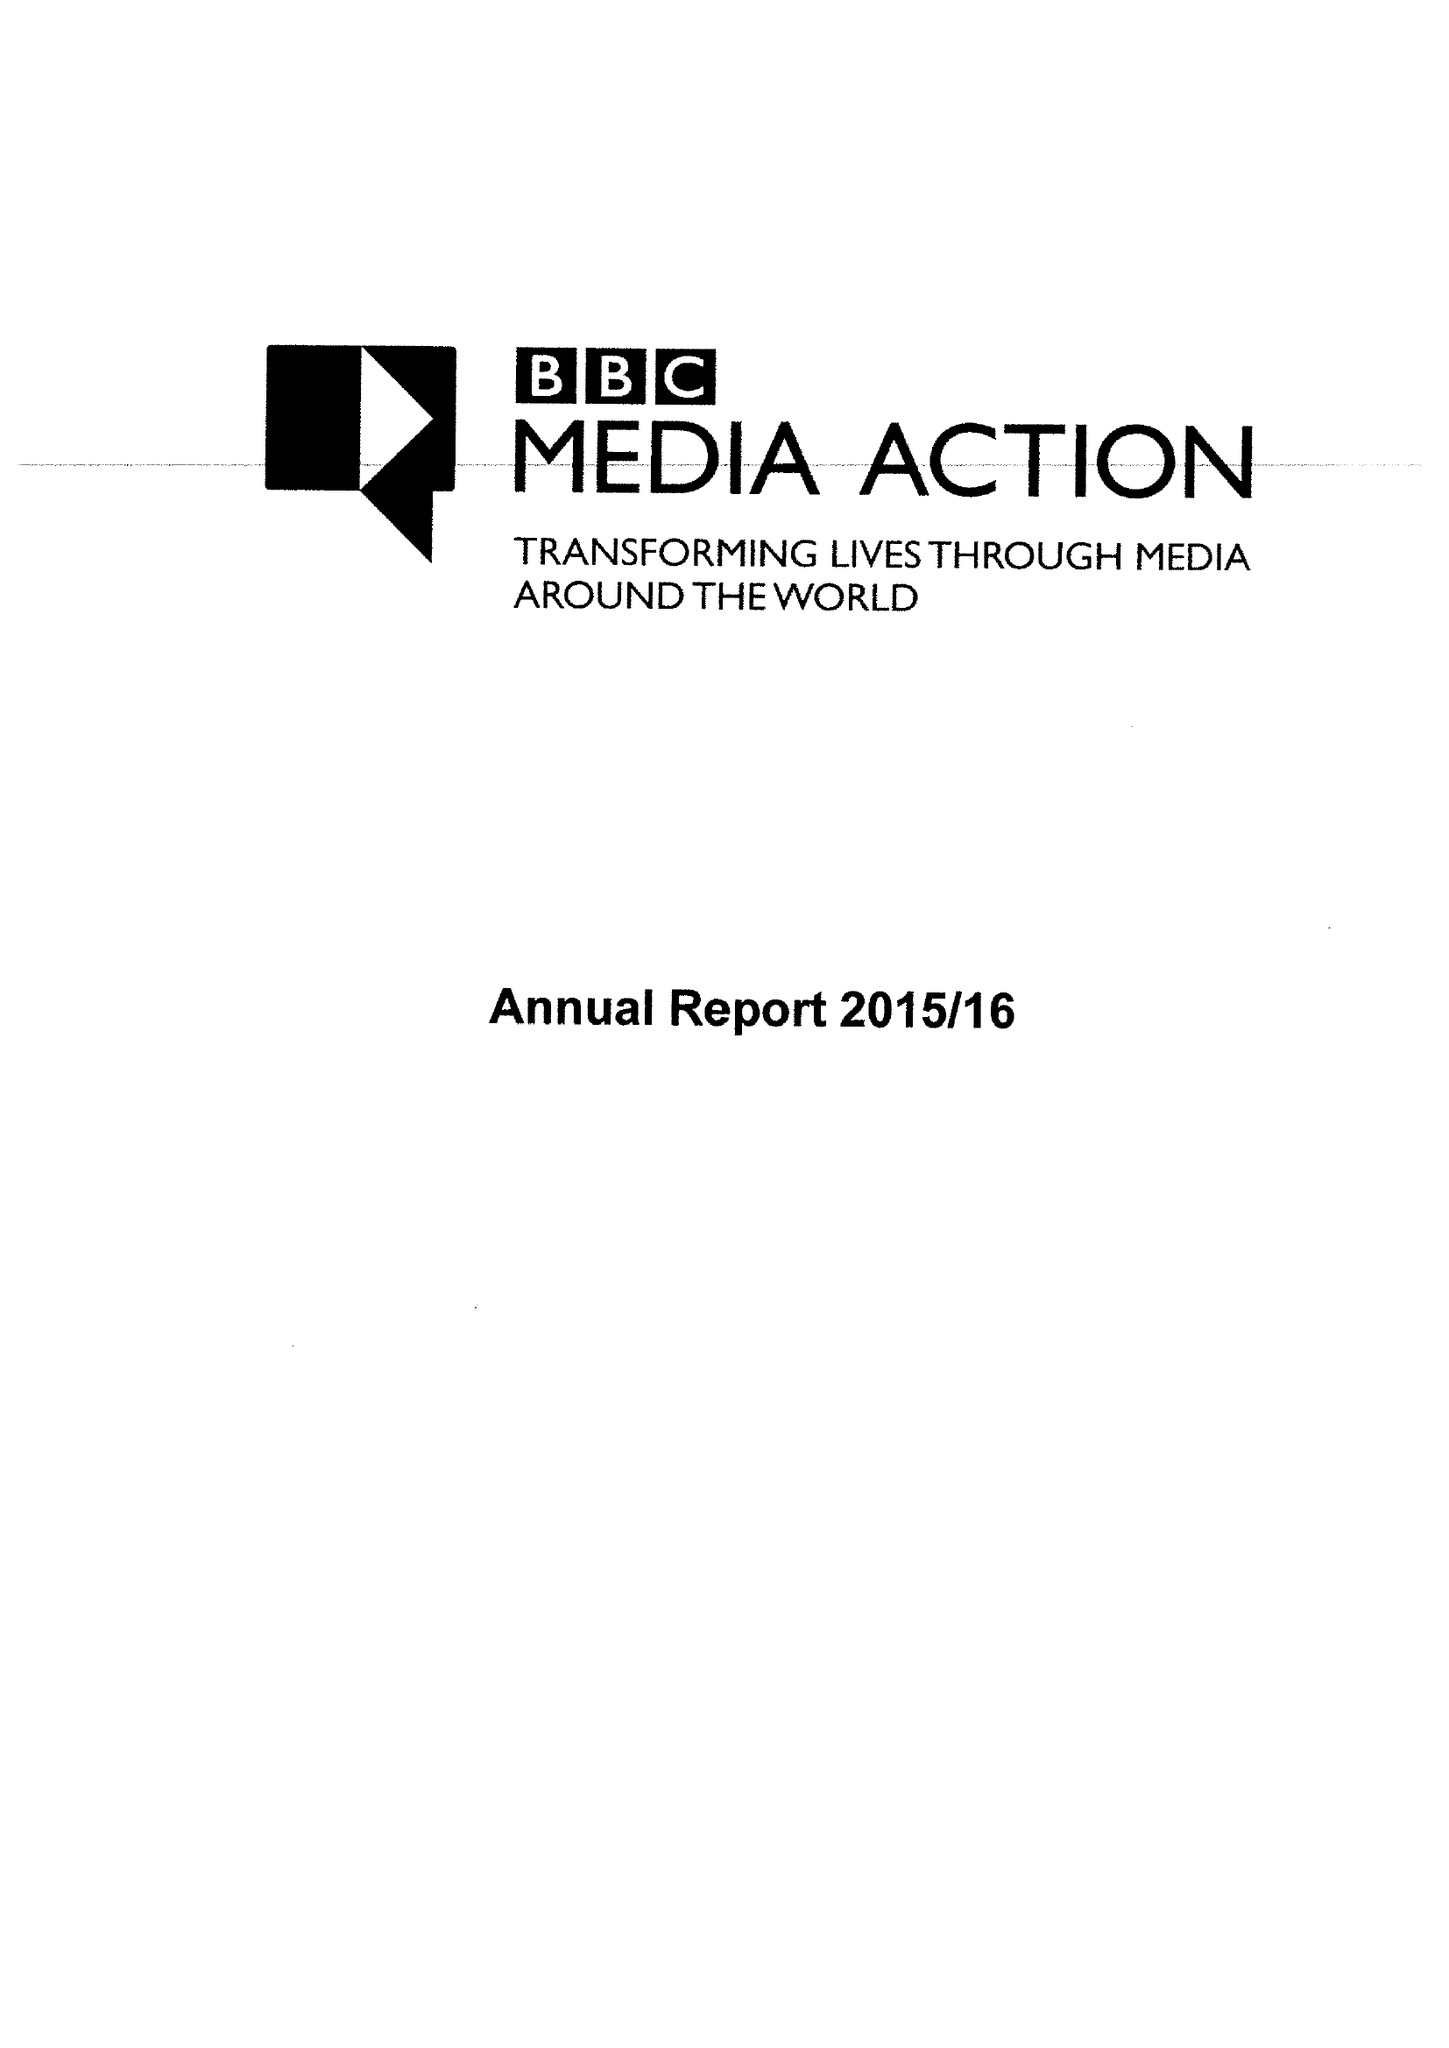What is the value for the address__postcode?
Answer the question using a single word or phrase. W1A 1AA 